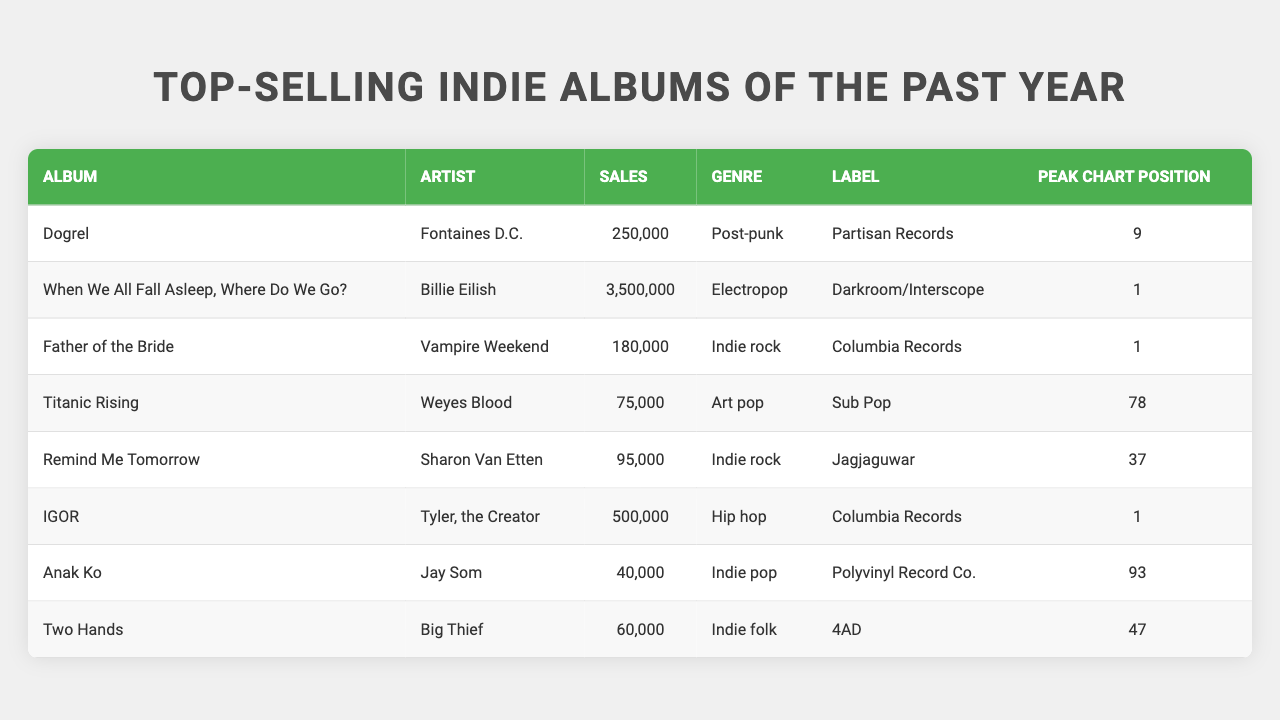What album had the highest sales? The album with the highest sales is "When We All Fall Asleep, Where Do We Go?" by Billie Eilish, with sales of 3,500,000.
Answer: When We All Fall Asleep, Where Do We Go? Which artist has the lowest-selling album? The artist with the lowest-selling album is Jay Som, with the album "Anak Ko" selling 40,000 copies.
Answer: Jay Som What genre is "Dogrel"? The genre of the album "Dogrel" is Post-punk.
Answer: Post-punk How many albums have sales over 200,000? There are two albums that have sales over 200,000: "When We All Fall Asleep, Where Do We Go?" and "IGOR".
Answer: 2 What is the average sales of all the albums listed in the table? To find the average, sum all the sales: 250,000 + 3,500,000 + 180,000 + 75,000 + 95,000 + 500,000 + 40,000 + 60,000 = 4,700,000. There are 8 albums, so the average is 4,700,000 / 8 = 587,500.
Answer: 587,500 Which album peaked at position 1? The albums that peaked at position 1 are "When We All Fall Asleep, Where Do We Go?", "Father of the Bride", and "IGOR".
Answer: 3 albums Did any album reach the top ten in sales? Yes, the album "When We All Fall Asleep, Where Do We Go?" by Billie Eilish reached the top ten with a peak chart position of 1.
Answer: Yes What's the total sales of albums by Vampire Weekend and Fontaines D.C.? The total sales are 180,000 (Vampire Weekend) + 250,000 (Fontaines D.C.) = 430,000.
Answer: 430,000 Which label has the most albums listed? Each label has a different number of albums: all listed artists have only one album represented. Therefore, no label has more than one.
Answer: No label has more than one album listed Are there any albums from the genre 'Indie rock'? Yes, there are two albums from the genre 'Indie rock': "Father of the Bride" by Vampire Weekend and "Remind Me Tomorrow" by Sharon Van Etten.
Answer: Yes 